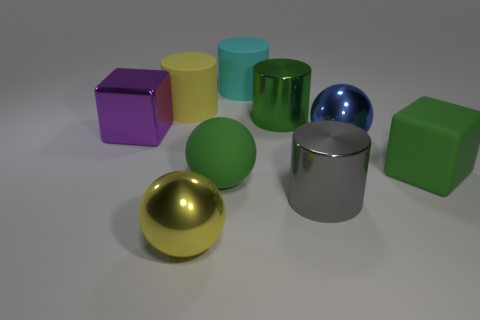What number of things are both left of the cyan rubber thing and on the right side of the large purple cube? There are two objects that meet the criteria of being to the left of the cyan rubber object and on the right side of the large purple cube – these are the small green sphere and the silver cylinder. 